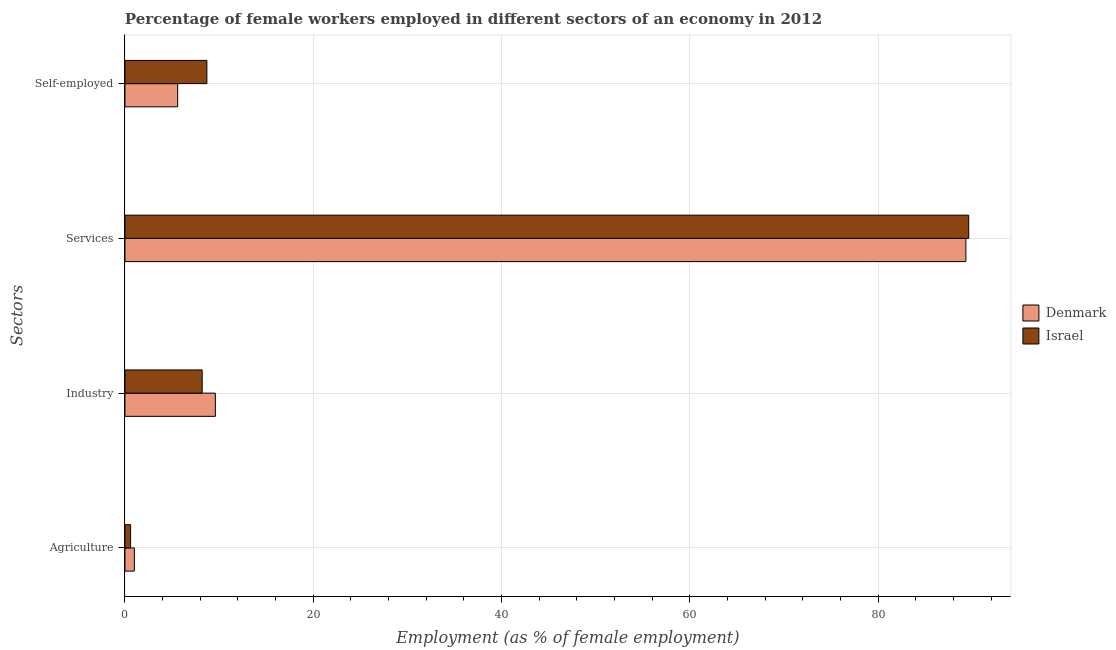How many different coloured bars are there?
Make the answer very short. 2. How many groups of bars are there?
Your answer should be compact. 4. Are the number of bars per tick equal to the number of legend labels?
Provide a succinct answer. Yes. How many bars are there on the 3rd tick from the top?
Offer a very short reply. 2. What is the label of the 2nd group of bars from the top?
Offer a terse response. Services. What is the percentage of female workers in agriculture in Israel?
Offer a very short reply. 0.6. Across all countries, what is the maximum percentage of female workers in services?
Your answer should be very brief. 89.6. Across all countries, what is the minimum percentage of self employed female workers?
Offer a terse response. 5.6. In which country was the percentage of female workers in industry maximum?
Provide a short and direct response. Denmark. What is the total percentage of self employed female workers in the graph?
Give a very brief answer. 14.3. What is the difference between the percentage of self employed female workers in Denmark and that in Israel?
Your answer should be very brief. -3.1. What is the difference between the percentage of self employed female workers in Denmark and the percentage of female workers in industry in Israel?
Give a very brief answer. -2.6. What is the average percentage of self employed female workers per country?
Your answer should be very brief. 7.15. What is the difference between the percentage of female workers in services and percentage of female workers in industry in Denmark?
Your response must be concise. 79.7. What is the ratio of the percentage of female workers in services in Israel to that in Denmark?
Ensure brevity in your answer.  1. Is the difference between the percentage of female workers in services in Denmark and Israel greater than the difference between the percentage of self employed female workers in Denmark and Israel?
Give a very brief answer. Yes. What is the difference between the highest and the second highest percentage of female workers in industry?
Provide a succinct answer. 1.4. What is the difference between the highest and the lowest percentage of female workers in industry?
Make the answer very short. 1.4. Is the sum of the percentage of self employed female workers in Denmark and Israel greater than the maximum percentage of female workers in services across all countries?
Your answer should be very brief. No. Is it the case that in every country, the sum of the percentage of female workers in services and percentage of female workers in industry is greater than the sum of percentage of self employed female workers and percentage of female workers in agriculture?
Offer a terse response. Yes. What does the 2nd bar from the top in Self-employed represents?
Offer a very short reply. Denmark. Is it the case that in every country, the sum of the percentage of female workers in agriculture and percentage of female workers in industry is greater than the percentage of female workers in services?
Offer a very short reply. No. How many bars are there?
Offer a terse response. 8. Are the values on the major ticks of X-axis written in scientific E-notation?
Your answer should be compact. No. Where does the legend appear in the graph?
Ensure brevity in your answer.  Center right. What is the title of the graph?
Offer a very short reply. Percentage of female workers employed in different sectors of an economy in 2012. Does "Poland" appear as one of the legend labels in the graph?
Give a very brief answer. No. What is the label or title of the X-axis?
Your answer should be very brief. Employment (as % of female employment). What is the label or title of the Y-axis?
Your answer should be very brief. Sectors. What is the Employment (as % of female employment) of Denmark in Agriculture?
Your response must be concise. 1. What is the Employment (as % of female employment) of Israel in Agriculture?
Keep it short and to the point. 0.6. What is the Employment (as % of female employment) in Denmark in Industry?
Provide a short and direct response. 9.6. What is the Employment (as % of female employment) in Israel in Industry?
Make the answer very short. 8.2. What is the Employment (as % of female employment) of Denmark in Services?
Keep it short and to the point. 89.3. What is the Employment (as % of female employment) in Israel in Services?
Your answer should be compact. 89.6. What is the Employment (as % of female employment) in Denmark in Self-employed?
Keep it short and to the point. 5.6. What is the Employment (as % of female employment) of Israel in Self-employed?
Your answer should be very brief. 8.7. Across all Sectors, what is the maximum Employment (as % of female employment) in Denmark?
Give a very brief answer. 89.3. Across all Sectors, what is the maximum Employment (as % of female employment) in Israel?
Offer a terse response. 89.6. Across all Sectors, what is the minimum Employment (as % of female employment) in Denmark?
Your response must be concise. 1. Across all Sectors, what is the minimum Employment (as % of female employment) in Israel?
Give a very brief answer. 0.6. What is the total Employment (as % of female employment) in Denmark in the graph?
Provide a short and direct response. 105.5. What is the total Employment (as % of female employment) in Israel in the graph?
Provide a succinct answer. 107.1. What is the difference between the Employment (as % of female employment) in Israel in Agriculture and that in Industry?
Your answer should be compact. -7.6. What is the difference between the Employment (as % of female employment) in Denmark in Agriculture and that in Services?
Your response must be concise. -88.3. What is the difference between the Employment (as % of female employment) in Israel in Agriculture and that in Services?
Give a very brief answer. -89. What is the difference between the Employment (as % of female employment) in Denmark in Agriculture and that in Self-employed?
Provide a succinct answer. -4.6. What is the difference between the Employment (as % of female employment) in Israel in Agriculture and that in Self-employed?
Offer a terse response. -8.1. What is the difference between the Employment (as % of female employment) in Denmark in Industry and that in Services?
Keep it short and to the point. -79.7. What is the difference between the Employment (as % of female employment) of Israel in Industry and that in Services?
Give a very brief answer. -81.4. What is the difference between the Employment (as % of female employment) in Israel in Industry and that in Self-employed?
Make the answer very short. -0.5. What is the difference between the Employment (as % of female employment) in Denmark in Services and that in Self-employed?
Make the answer very short. 83.7. What is the difference between the Employment (as % of female employment) of Israel in Services and that in Self-employed?
Provide a short and direct response. 80.9. What is the difference between the Employment (as % of female employment) in Denmark in Agriculture and the Employment (as % of female employment) in Israel in Services?
Keep it short and to the point. -88.6. What is the difference between the Employment (as % of female employment) in Denmark in Industry and the Employment (as % of female employment) in Israel in Services?
Your answer should be compact. -80. What is the difference between the Employment (as % of female employment) of Denmark in Services and the Employment (as % of female employment) of Israel in Self-employed?
Your answer should be very brief. 80.6. What is the average Employment (as % of female employment) in Denmark per Sectors?
Your response must be concise. 26.38. What is the average Employment (as % of female employment) of Israel per Sectors?
Give a very brief answer. 26.77. What is the ratio of the Employment (as % of female employment) in Denmark in Agriculture to that in Industry?
Ensure brevity in your answer.  0.1. What is the ratio of the Employment (as % of female employment) in Israel in Agriculture to that in Industry?
Ensure brevity in your answer.  0.07. What is the ratio of the Employment (as % of female employment) of Denmark in Agriculture to that in Services?
Ensure brevity in your answer.  0.01. What is the ratio of the Employment (as % of female employment) of Israel in Agriculture to that in Services?
Provide a short and direct response. 0.01. What is the ratio of the Employment (as % of female employment) in Denmark in Agriculture to that in Self-employed?
Offer a very short reply. 0.18. What is the ratio of the Employment (as % of female employment) of Israel in Agriculture to that in Self-employed?
Provide a short and direct response. 0.07. What is the ratio of the Employment (as % of female employment) in Denmark in Industry to that in Services?
Make the answer very short. 0.11. What is the ratio of the Employment (as % of female employment) in Israel in Industry to that in Services?
Give a very brief answer. 0.09. What is the ratio of the Employment (as % of female employment) in Denmark in Industry to that in Self-employed?
Keep it short and to the point. 1.71. What is the ratio of the Employment (as % of female employment) in Israel in Industry to that in Self-employed?
Your answer should be very brief. 0.94. What is the ratio of the Employment (as % of female employment) of Denmark in Services to that in Self-employed?
Your answer should be compact. 15.95. What is the ratio of the Employment (as % of female employment) in Israel in Services to that in Self-employed?
Offer a terse response. 10.3. What is the difference between the highest and the second highest Employment (as % of female employment) in Denmark?
Offer a terse response. 79.7. What is the difference between the highest and the second highest Employment (as % of female employment) in Israel?
Your answer should be very brief. 80.9. What is the difference between the highest and the lowest Employment (as % of female employment) in Denmark?
Your response must be concise. 88.3. What is the difference between the highest and the lowest Employment (as % of female employment) in Israel?
Give a very brief answer. 89. 